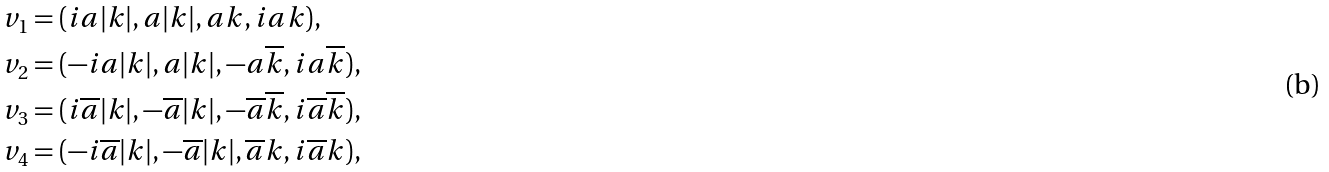Convert formula to latex. <formula><loc_0><loc_0><loc_500><loc_500>& v _ { 1 } = ( i a | k | , a | k | , a k , i a k ) , \\ & v _ { 2 } = ( - i a | k | , a | k | , - a \overline { k } , i a \overline { k } ) , \\ & v _ { 3 } = ( i \overline { a } | k | , - \overline { a } | k | , - \overline { a } \overline { k } , i \overline { a } \overline { k } ) , \\ & v _ { 4 } = ( - i \overline { a } | k | , - \overline { a } | k | , \overline { a } k , i \overline { a } k ) ,</formula> 